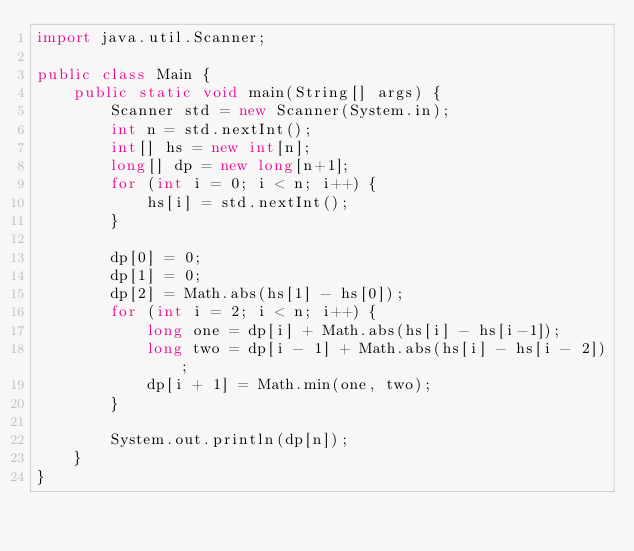Convert code to text. <code><loc_0><loc_0><loc_500><loc_500><_Java_>import java.util.Scanner;

public class Main {
    public static void main(String[] args) {
        Scanner std = new Scanner(System.in);
        int n = std.nextInt();
        int[] hs = new int[n];
        long[] dp = new long[n+1];
        for (int i = 0; i < n; i++) {
            hs[i] = std.nextInt();
        }

        dp[0] = 0;
        dp[1] = 0;
        dp[2] = Math.abs(hs[1] - hs[0]);
        for (int i = 2; i < n; i++) {
            long one = dp[i] + Math.abs(hs[i] - hs[i-1]);
            long two = dp[i - 1] + Math.abs(hs[i] - hs[i - 2]);
            dp[i + 1] = Math.min(one, two);
        }

        System.out.println(dp[n]);
    }
}
</code> 